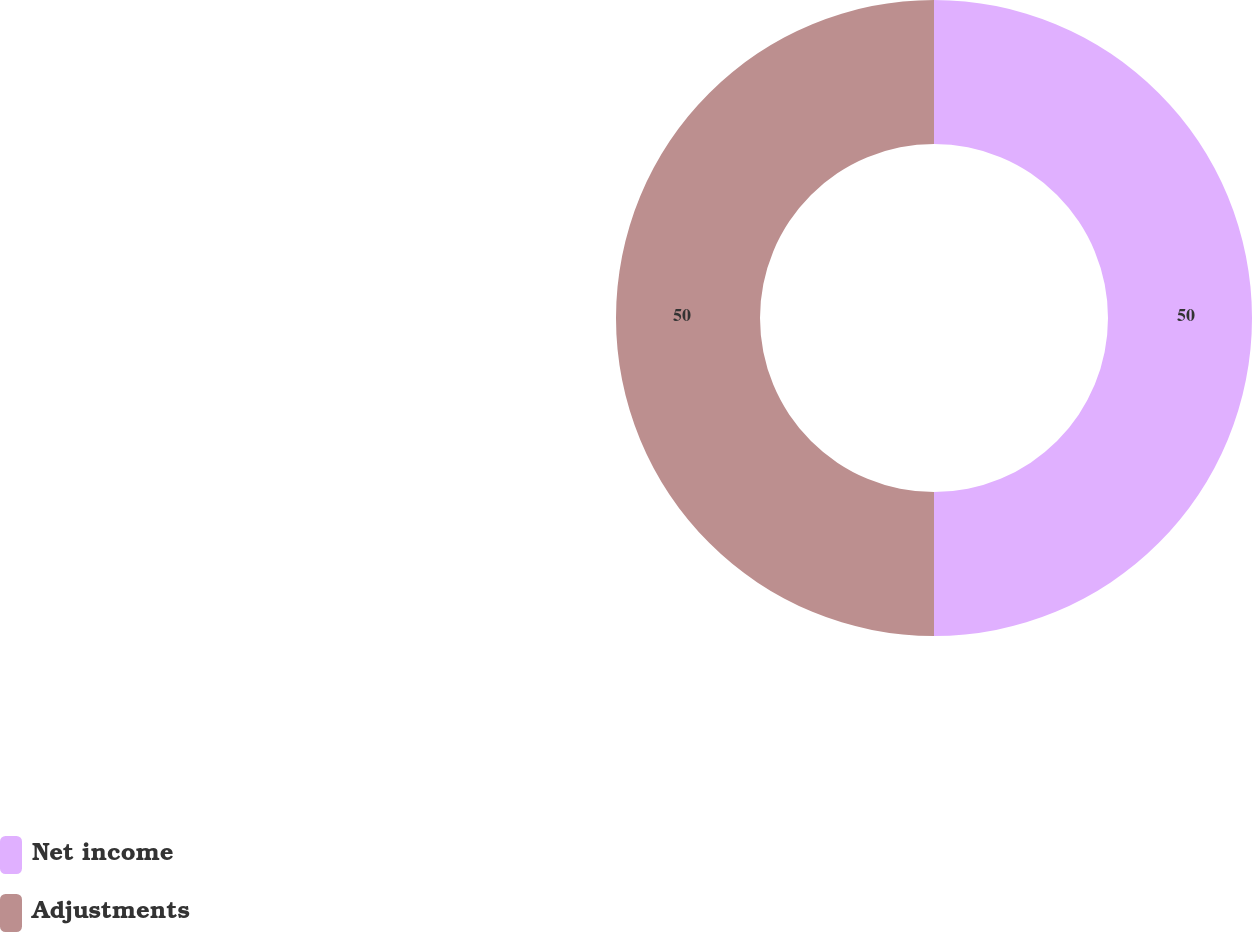Convert chart. <chart><loc_0><loc_0><loc_500><loc_500><pie_chart><fcel>Net income<fcel>Adjustments<nl><fcel>50.0%<fcel>50.0%<nl></chart> 